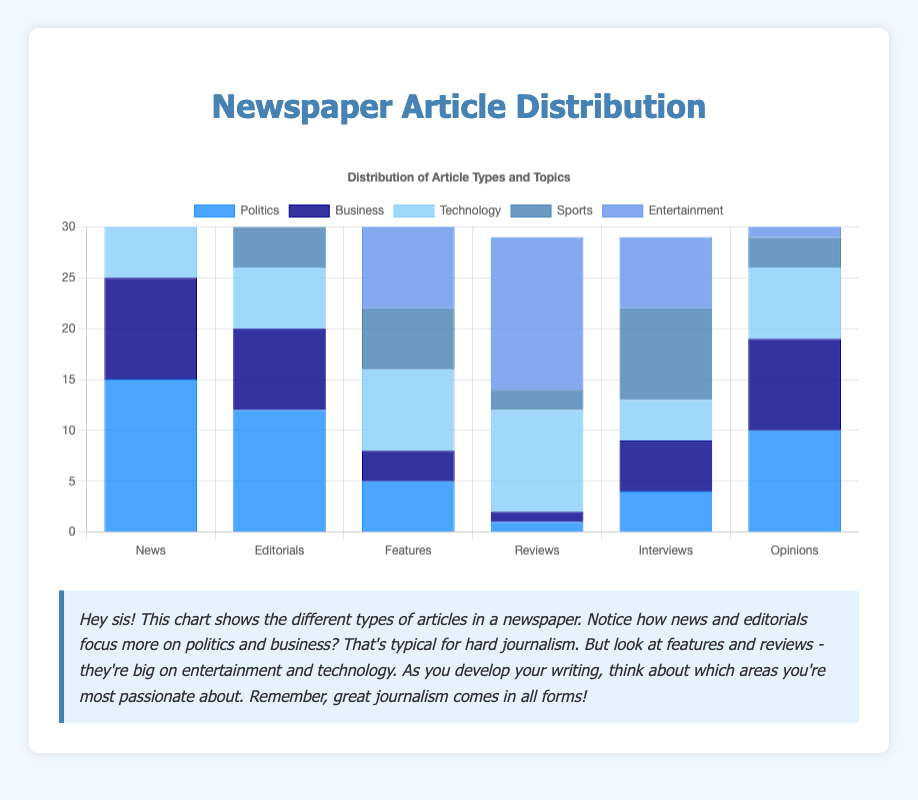Which type of article has the highest number of politics articles? The bar for 'News' in the 'Politics' category is the tallest, indicating that 'News' articles contain the most politics articles.
Answer: News Which section has the most entertainment articles? The bar for 'Reviews' in the 'Entertainment' category is the tallest, indicating that 'Reviews' has the highest number of entertainment articles.
Answer: Reviews How many more sports articles are there in 'Interviews' compared to 'News'? The 'Interviews' section has 9 sports articles, and the 'News' section has 6 sports articles. The difference is 9 - 6 = 3.
Answer: 3 What is the total number of technology articles across all types? Add the technology articles for each type: 7 (News) + 6 (Editorials) + 8 (Features) + 10 (Reviews) + 4 (Interviews) + 7 (Opinions) = 42.
Answer: 42 Which article type has fewer business articles, 'Features' or 'Reviews'? The 'Features' section has 3 business articles, and the 'Reviews' section has 1 business article. Therefore, 'Reviews' has fewer business articles.
Answer: Reviews Compare the distribution of business articles in 'News' and 'Editorials'. 'News' has 10 business articles, and 'Editorials' has 8. Therefore, 'News' has slightly more business articles than 'Editorials'.
Answer: News Which two categories have the most similar number of articles in the 'Editorials' type? 'Technology' has 6 articles and 'Sports' has 4 articles in the 'Editorials' type. These are the two closest numbers.
Answer: Technology and Sports What is the average number of politics articles in ‘News’, ‘Features’, and ‘Opinions’? Add the number of politics articles in 'News' (15), 'Features' (5), and 'Opinions' (10). The sum is 15 + 5 + 10 = 30. Divide by 3 to get the average: 30 / 3 = 10.
Answer: 10 